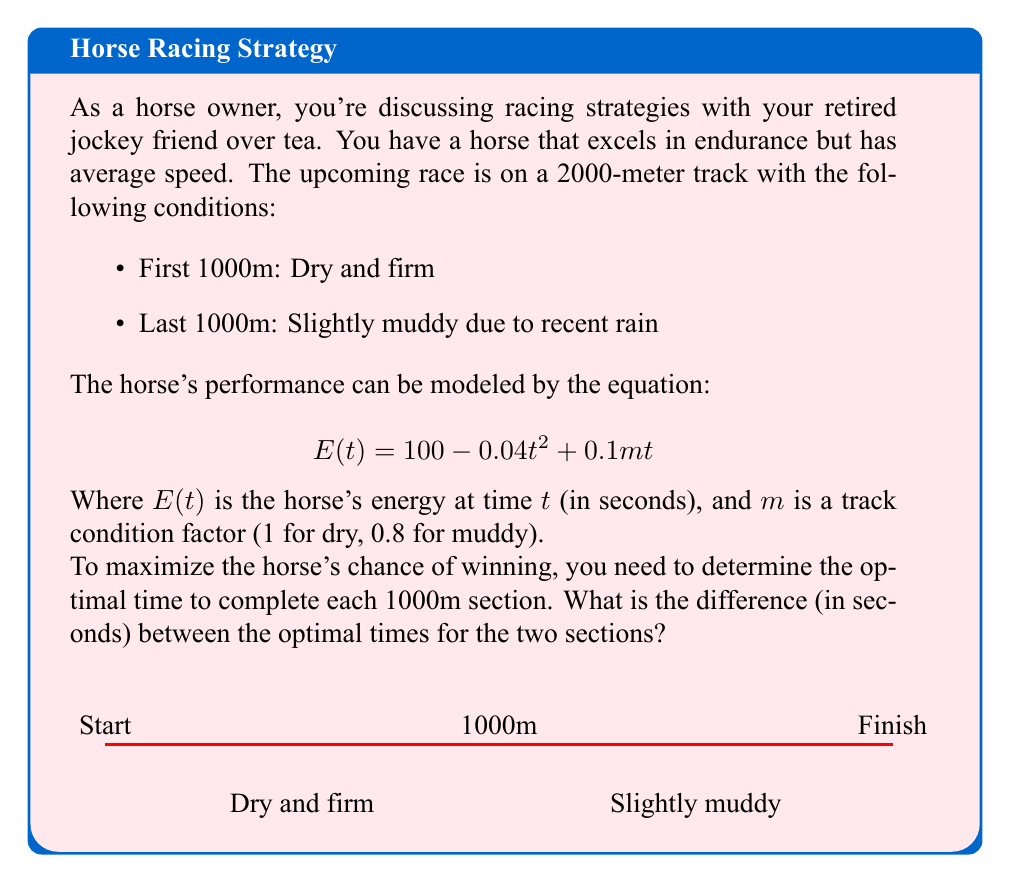Give your solution to this math problem. Let's approach this step-by-step:

1) We need to find the optimal time for each 1000m section. The optimal time will be when the horse's energy is at its maximum.

2) For the first 1000m (dry section), $m = 1$. The energy equation is:
   $$E_1(t) = 100 - 0.04t^2 + 0.1t$$

3) For the second 1000m (muddy section), $m = 0.8$. The energy equation is:
   $$E_2(t) = 100 - 0.04t^2 + 0.08t$$

4) To find the maximum energy point, we differentiate each equation and set it to zero:

   For $E_1(t)$: $$\frac{dE_1}{dt} = -0.08t + 0.1 = 0$$
   $$0.08t = 0.1$$
   $$t_1 = 1.25 \text{ seconds}$$

   For $E_2(t)$: $$\frac{dE_2}{dt} = -0.08t + 0.08 = 0$$
   $$0.08t = 0.08$$
   $$t_2 = 1 \text{ second}$$

5) These values represent the time per meter at peak efficiency. To find the time for 1000m:

   Dry section: $1000 * 1.25 = 1250 \text{ seconds}$
   Muddy section: $1000 * 1 = 1000 \text{ seconds}$

6) The difference between these optimal times is:
   $1250 - 1000 = 250 \text{ seconds}$
Answer: 250 seconds 